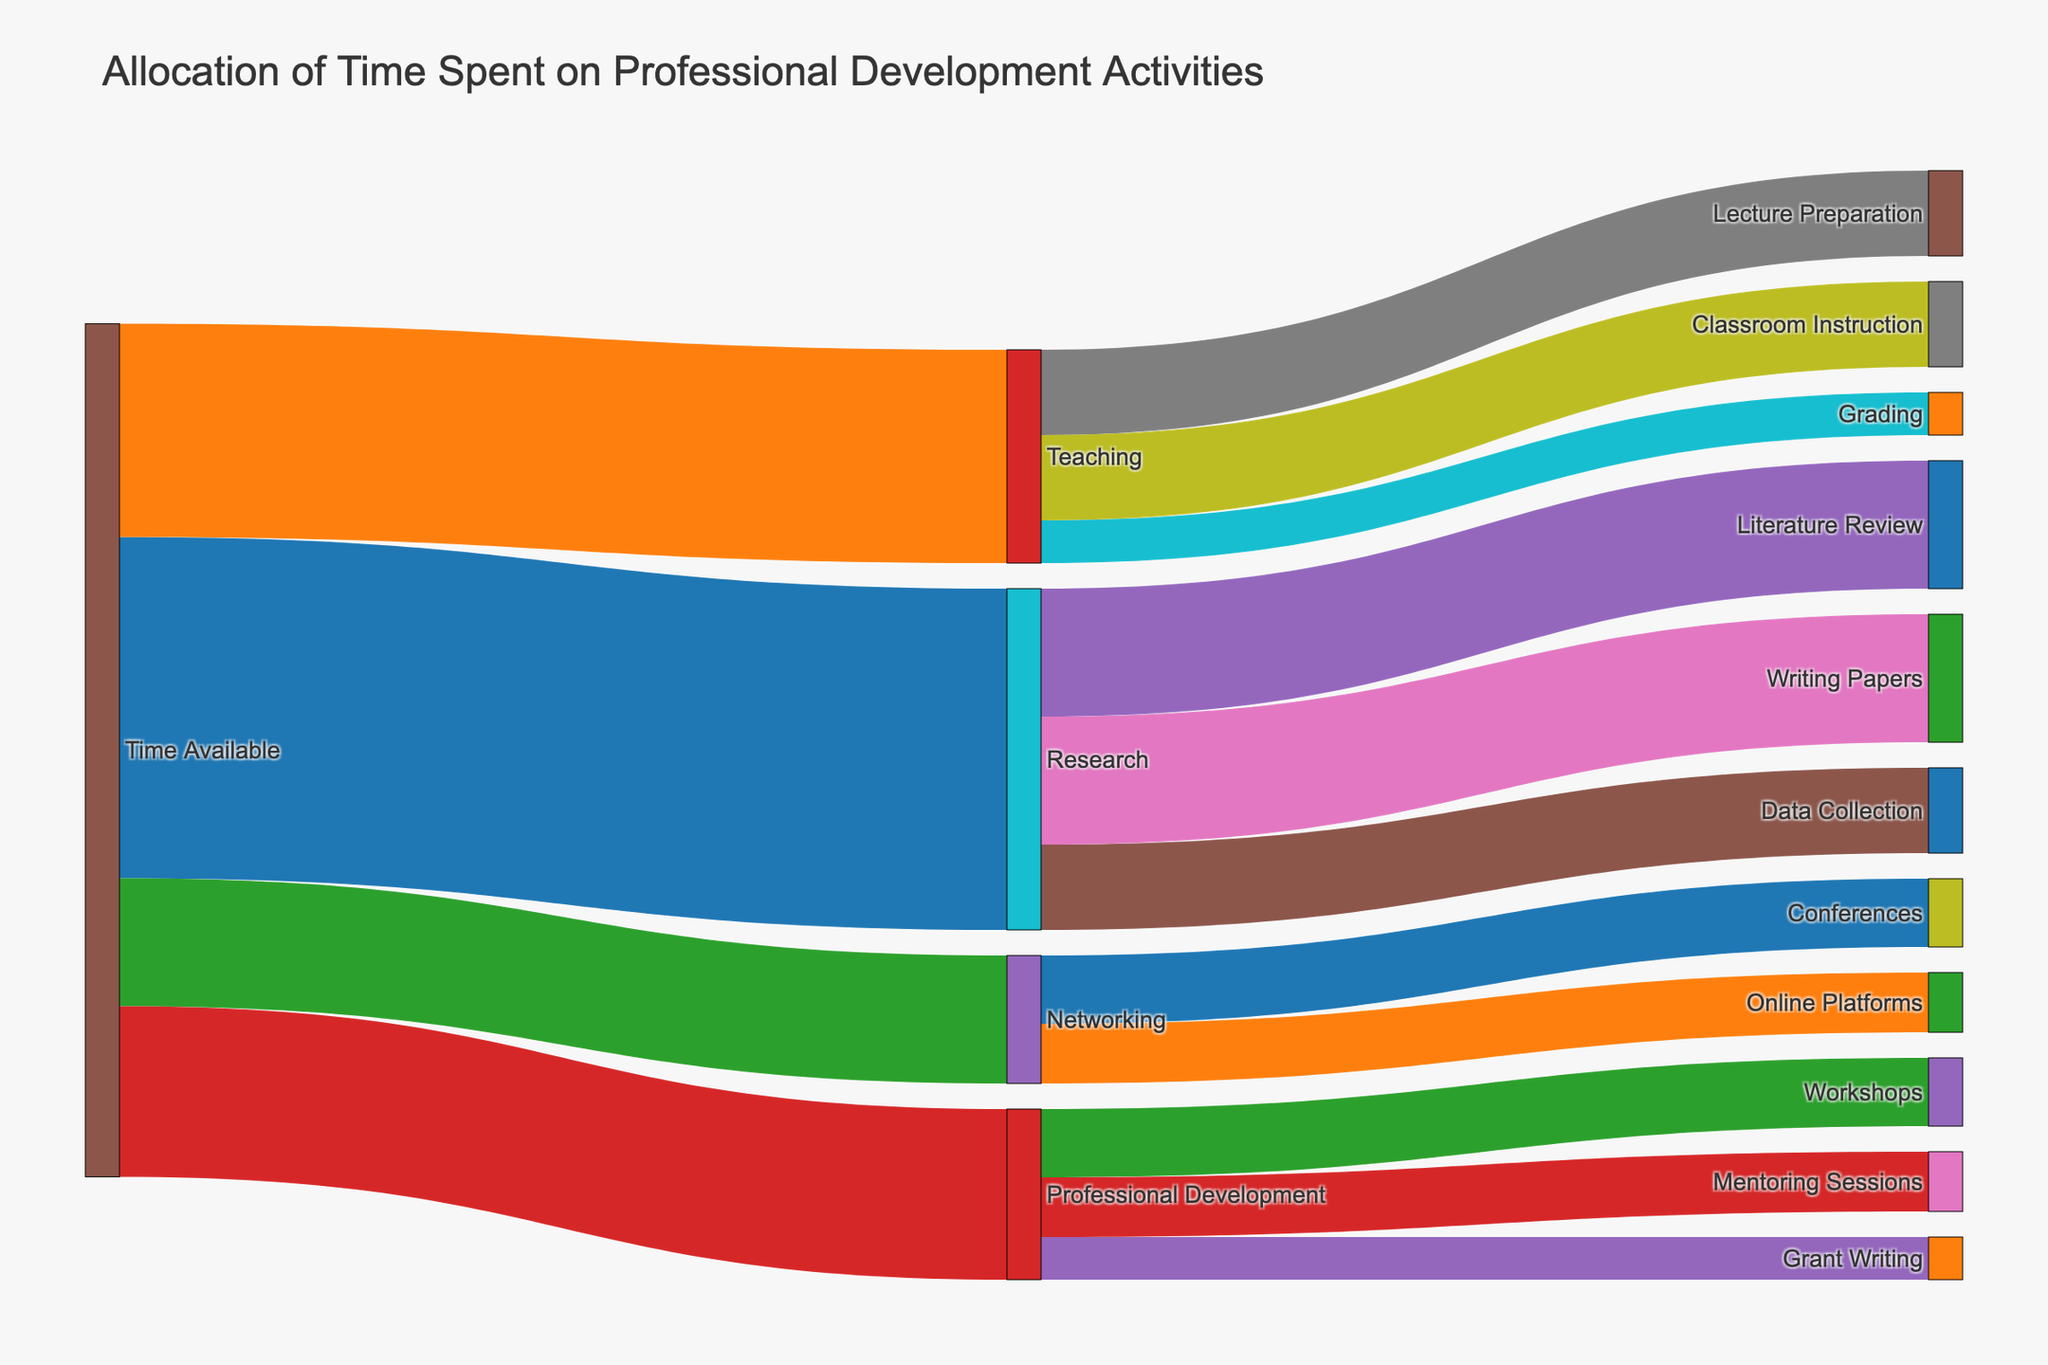How much time is allocated to research activities? Follow the flow from "Time Available" to "Research" in the Sankey diagram. The value associated with this flow is 40.
Answer: 40 Which activity under professional development receives the most time allocation? Look at the branches from "Professional Development" to its subcategories. "Workshops" receive a value of 8, which is the highest compared to "Mentoring Sessions" (7) and "Grant Writing" (5).
Answer: Workshops How does the time spent on grant writing compare with data collection? Compare the values for "Grant Writing" (5) and "Data Collection" (10) in the chart. Data Collection has a higher value.
Answer: Data Collection is greater What percentage of the total available time is allocated to networking? The value for "Time Available" to "Networking" is 15. The total available time is 100 (sum of 40 + 25 + 15 + 20). So, the percentage is (15/100) * 100%.
Answer: 15% What is the total time spent on literature review and writing papers? Sum the values for "Literature Review" (15) and "Writing Papers" (15) under the "Research" category. The total is 15 + 15.
Answer: 30 Which two activities within teaching require the same amount of time? Under "Teaching", "Lecture Preparation" and "Classroom Instruction" both have values of 10.
Answer: Lecture Preparation and Classroom Instruction Is more time spent on mentoring sessions or conferences? Compare the values for "Mentoring Sessions" (7) and "Conferences" (8). Conferences have a higher value.
Answer: Conferences Calculate the total time spent on professional development activities. Sum the values for "Workshops" (8), "Mentoring Sessions" (7), and "Grant Writing" (5). The total is 8 + 7 + 5.
Answer: 20 Which is the least time-consuming activity mentioned in the diagram? Among all the activities, "Grant Writing" has the lowest value of 5.
Answer: Grant Writing 